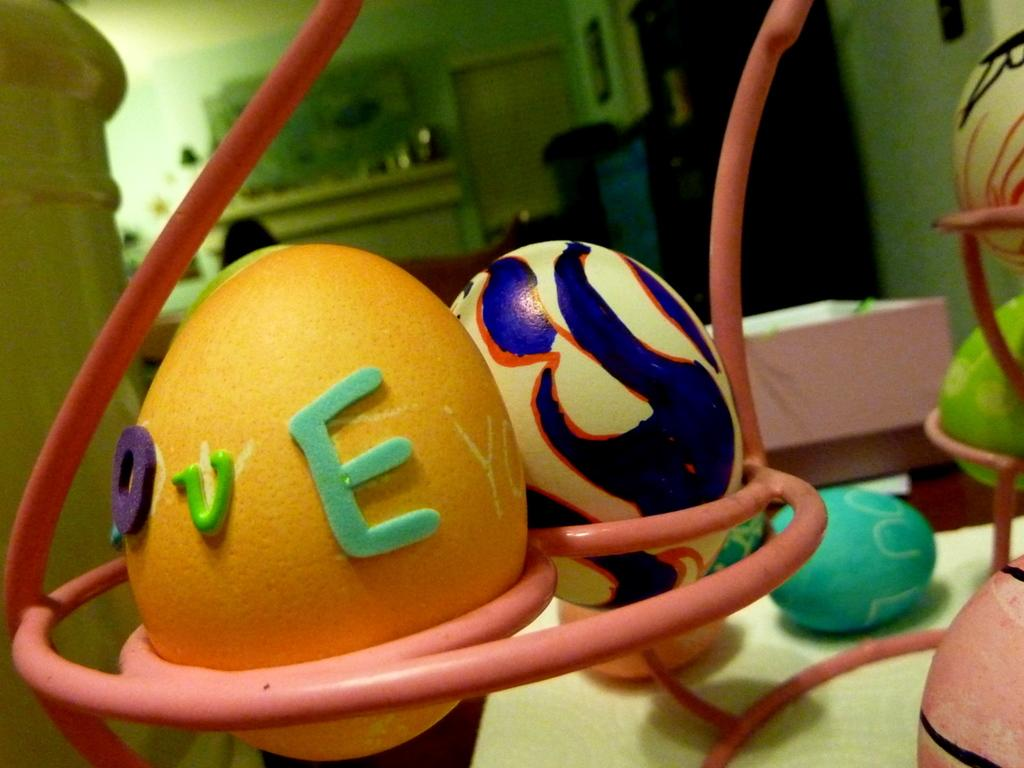What type of items can be seen in the tray in the image? There are easter eggs in a tray in the image. What type of furniture is visible in the image? There are cupboards and tables visible in the image. Where is the door located in the image? The door is in the middle of the wall in the image. Can you describe the ocean visible through the door in the image? There is no ocean visible through the door in the image; it is a door in the middle of a wall. 